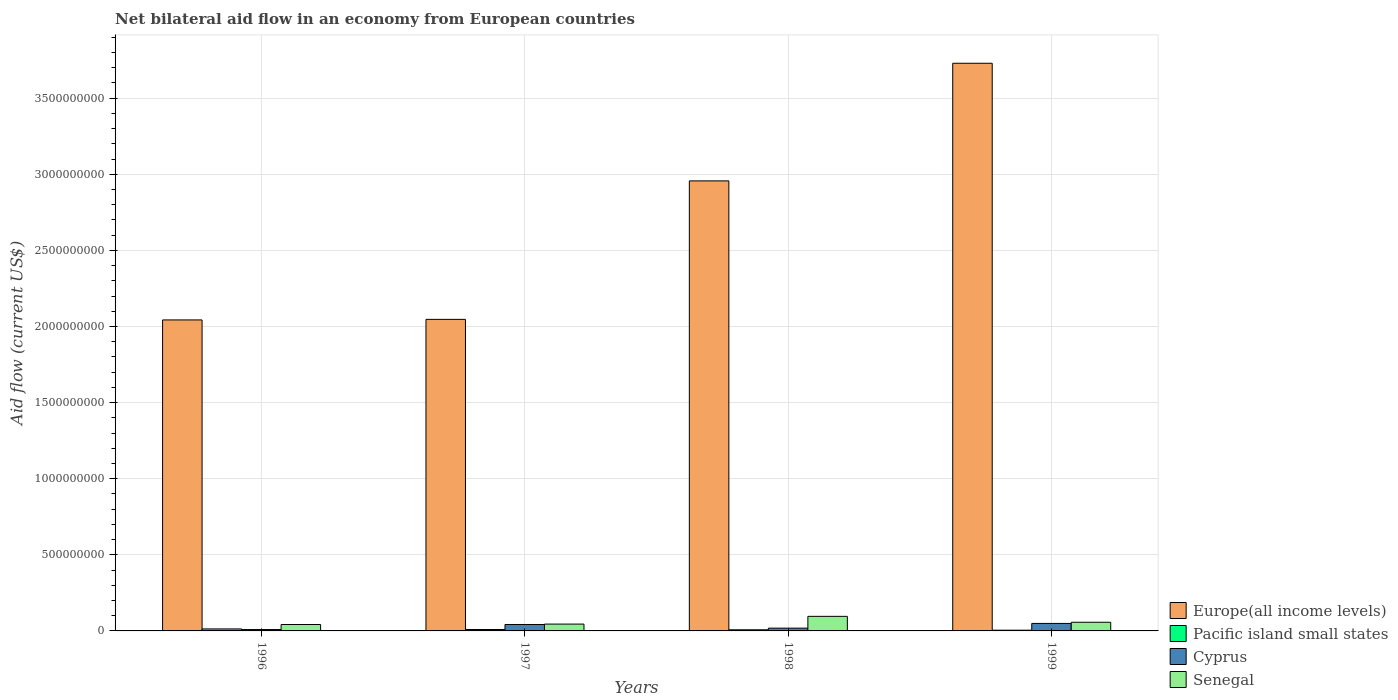How many different coloured bars are there?
Offer a terse response. 4. How many groups of bars are there?
Keep it short and to the point. 4. Are the number of bars per tick equal to the number of legend labels?
Give a very brief answer. Yes. Are the number of bars on each tick of the X-axis equal?
Keep it short and to the point. Yes. In how many cases, is the number of bars for a given year not equal to the number of legend labels?
Provide a succinct answer. 0. What is the net bilateral aid flow in Senegal in 1999?
Ensure brevity in your answer.  5.70e+07. Across all years, what is the maximum net bilateral aid flow in Europe(all income levels)?
Provide a succinct answer. 3.73e+09. Across all years, what is the minimum net bilateral aid flow in Cyprus?
Provide a succinct answer. 8.99e+06. What is the total net bilateral aid flow in Europe(all income levels) in the graph?
Your response must be concise. 1.08e+1. What is the difference between the net bilateral aid flow in Cyprus in 1996 and that in 1998?
Ensure brevity in your answer.  -9.24e+06. What is the difference between the net bilateral aid flow in Pacific island small states in 1998 and the net bilateral aid flow in Europe(all income levels) in 1999?
Ensure brevity in your answer.  -3.72e+09. What is the average net bilateral aid flow in Pacific island small states per year?
Give a very brief answer. 8.67e+06. In the year 1998, what is the difference between the net bilateral aid flow in Pacific island small states and net bilateral aid flow in Senegal?
Your response must be concise. -8.83e+07. In how many years, is the net bilateral aid flow in Cyprus greater than 800000000 US$?
Your answer should be compact. 0. What is the ratio of the net bilateral aid flow in Cyprus in 1996 to that in 1998?
Give a very brief answer. 0.49. Is the net bilateral aid flow in Senegal in 1997 less than that in 1999?
Make the answer very short. Yes. What is the difference between the highest and the second highest net bilateral aid flow in Pacific island small states?
Give a very brief answer. 3.94e+06. What is the difference between the highest and the lowest net bilateral aid flow in Senegal?
Keep it short and to the point. 5.36e+07. Is it the case that in every year, the sum of the net bilateral aid flow in Pacific island small states and net bilateral aid flow in Senegal is greater than the sum of net bilateral aid flow in Europe(all income levels) and net bilateral aid flow in Cyprus?
Make the answer very short. No. What does the 2nd bar from the left in 1999 represents?
Offer a terse response. Pacific island small states. What does the 2nd bar from the right in 1997 represents?
Your answer should be very brief. Cyprus. Is it the case that in every year, the sum of the net bilateral aid flow in Europe(all income levels) and net bilateral aid flow in Cyprus is greater than the net bilateral aid flow in Senegal?
Your response must be concise. Yes. Are all the bars in the graph horizontal?
Provide a succinct answer. No. Are the values on the major ticks of Y-axis written in scientific E-notation?
Your answer should be very brief. No. Does the graph contain any zero values?
Make the answer very short. No. How many legend labels are there?
Your response must be concise. 4. How are the legend labels stacked?
Offer a very short reply. Vertical. What is the title of the graph?
Offer a very short reply. Net bilateral aid flow in an economy from European countries. What is the label or title of the X-axis?
Offer a terse response. Years. What is the Aid flow (current US$) of Europe(all income levels) in 1996?
Provide a short and direct response. 2.04e+09. What is the Aid flow (current US$) of Pacific island small states in 1996?
Make the answer very short. 1.32e+07. What is the Aid flow (current US$) of Cyprus in 1996?
Give a very brief answer. 8.99e+06. What is the Aid flow (current US$) of Senegal in 1996?
Ensure brevity in your answer.  4.21e+07. What is the Aid flow (current US$) in Europe(all income levels) in 1997?
Provide a succinct answer. 2.05e+09. What is the Aid flow (current US$) of Pacific island small states in 1997?
Your answer should be compact. 9.26e+06. What is the Aid flow (current US$) of Cyprus in 1997?
Your answer should be compact. 4.23e+07. What is the Aid flow (current US$) in Senegal in 1997?
Offer a terse response. 4.50e+07. What is the Aid flow (current US$) of Europe(all income levels) in 1998?
Make the answer very short. 2.96e+09. What is the Aid flow (current US$) in Pacific island small states in 1998?
Your answer should be very brief. 7.39e+06. What is the Aid flow (current US$) in Cyprus in 1998?
Your response must be concise. 1.82e+07. What is the Aid flow (current US$) of Senegal in 1998?
Ensure brevity in your answer.  9.57e+07. What is the Aid flow (current US$) of Europe(all income levels) in 1999?
Offer a terse response. 3.73e+09. What is the Aid flow (current US$) in Pacific island small states in 1999?
Your answer should be compact. 4.82e+06. What is the Aid flow (current US$) in Cyprus in 1999?
Offer a very short reply. 4.92e+07. What is the Aid flow (current US$) of Senegal in 1999?
Your response must be concise. 5.70e+07. Across all years, what is the maximum Aid flow (current US$) of Europe(all income levels)?
Offer a terse response. 3.73e+09. Across all years, what is the maximum Aid flow (current US$) of Pacific island small states?
Provide a short and direct response. 1.32e+07. Across all years, what is the maximum Aid flow (current US$) in Cyprus?
Provide a succinct answer. 4.92e+07. Across all years, what is the maximum Aid flow (current US$) in Senegal?
Offer a terse response. 9.57e+07. Across all years, what is the minimum Aid flow (current US$) in Europe(all income levels)?
Make the answer very short. 2.04e+09. Across all years, what is the minimum Aid flow (current US$) in Pacific island small states?
Make the answer very short. 4.82e+06. Across all years, what is the minimum Aid flow (current US$) in Cyprus?
Provide a short and direct response. 8.99e+06. Across all years, what is the minimum Aid flow (current US$) of Senegal?
Make the answer very short. 4.21e+07. What is the total Aid flow (current US$) of Europe(all income levels) in the graph?
Provide a succinct answer. 1.08e+1. What is the total Aid flow (current US$) of Pacific island small states in the graph?
Offer a terse response. 3.47e+07. What is the total Aid flow (current US$) in Cyprus in the graph?
Make the answer very short. 1.19e+08. What is the total Aid flow (current US$) of Senegal in the graph?
Offer a very short reply. 2.40e+08. What is the difference between the Aid flow (current US$) of Europe(all income levels) in 1996 and that in 1997?
Provide a short and direct response. -3.69e+06. What is the difference between the Aid flow (current US$) of Pacific island small states in 1996 and that in 1997?
Offer a very short reply. 3.94e+06. What is the difference between the Aid flow (current US$) in Cyprus in 1996 and that in 1997?
Your response must be concise. -3.33e+07. What is the difference between the Aid flow (current US$) of Senegal in 1996 and that in 1997?
Provide a succinct answer. -2.83e+06. What is the difference between the Aid flow (current US$) of Europe(all income levels) in 1996 and that in 1998?
Provide a short and direct response. -9.14e+08. What is the difference between the Aid flow (current US$) in Pacific island small states in 1996 and that in 1998?
Ensure brevity in your answer.  5.81e+06. What is the difference between the Aid flow (current US$) in Cyprus in 1996 and that in 1998?
Your answer should be very brief. -9.24e+06. What is the difference between the Aid flow (current US$) in Senegal in 1996 and that in 1998?
Give a very brief answer. -5.36e+07. What is the difference between the Aid flow (current US$) in Europe(all income levels) in 1996 and that in 1999?
Offer a very short reply. -1.69e+09. What is the difference between the Aid flow (current US$) of Pacific island small states in 1996 and that in 1999?
Your response must be concise. 8.38e+06. What is the difference between the Aid flow (current US$) of Cyprus in 1996 and that in 1999?
Make the answer very short. -4.02e+07. What is the difference between the Aid flow (current US$) of Senegal in 1996 and that in 1999?
Make the answer very short. -1.48e+07. What is the difference between the Aid flow (current US$) in Europe(all income levels) in 1997 and that in 1998?
Provide a short and direct response. -9.10e+08. What is the difference between the Aid flow (current US$) in Pacific island small states in 1997 and that in 1998?
Your answer should be very brief. 1.87e+06. What is the difference between the Aid flow (current US$) of Cyprus in 1997 and that in 1998?
Offer a very short reply. 2.40e+07. What is the difference between the Aid flow (current US$) in Senegal in 1997 and that in 1998?
Offer a terse response. -5.08e+07. What is the difference between the Aid flow (current US$) in Europe(all income levels) in 1997 and that in 1999?
Offer a very short reply. -1.68e+09. What is the difference between the Aid flow (current US$) in Pacific island small states in 1997 and that in 1999?
Offer a terse response. 4.44e+06. What is the difference between the Aid flow (current US$) in Cyprus in 1997 and that in 1999?
Give a very brief answer. -6.93e+06. What is the difference between the Aid flow (current US$) in Senegal in 1997 and that in 1999?
Ensure brevity in your answer.  -1.20e+07. What is the difference between the Aid flow (current US$) of Europe(all income levels) in 1998 and that in 1999?
Ensure brevity in your answer.  -7.73e+08. What is the difference between the Aid flow (current US$) in Pacific island small states in 1998 and that in 1999?
Your response must be concise. 2.57e+06. What is the difference between the Aid flow (current US$) in Cyprus in 1998 and that in 1999?
Offer a terse response. -3.10e+07. What is the difference between the Aid flow (current US$) of Senegal in 1998 and that in 1999?
Ensure brevity in your answer.  3.88e+07. What is the difference between the Aid flow (current US$) in Europe(all income levels) in 1996 and the Aid flow (current US$) in Pacific island small states in 1997?
Provide a short and direct response. 2.03e+09. What is the difference between the Aid flow (current US$) in Europe(all income levels) in 1996 and the Aid flow (current US$) in Cyprus in 1997?
Provide a succinct answer. 2.00e+09. What is the difference between the Aid flow (current US$) in Europe(all income levels) in 1996 and the Aid flow (current US$) in Senegal in 1997?
Ensure brevity in your answer.  2.00e+09. What is the difference between the Aid flow (current US$) of Pacific island small states in 1996 and the Aid flow (current US$) of Cyprus in 1997?
Keep it short and to the point. -2.91e+07. What is the difference between the Aid flow (current US$) in Pacific island small states in 1996 and the Aid flow (current US$) in Senegal in 1997?
Offer a very short reply. -3.18e+07. What is the difference between the Aid flow (current US$) in Cyprus in 1996 and the Aid flow (current US$) in Senegal in 1997?
Make the answer very short. -3.60e+07. What is the difference between the Aid flow (current US$) of Europe(all income levels) in 1996 and the Aid flow (current US$) of Pacific island small states in 1998?
Ensure brevity in your answer.  2.04e+09. What is the difference between the Aid flow (current US$) in Europe(all income levels) in 1996 and the Aid flow (current US$) in Cyprus in 1998?
Ensure brevity in your answer.  2.03e+09. What is the difference between the Aid flow (current US$) of Europe(all income levels) in 1996 and the Aid flow (current US$) of Senegal in 1998?
Your response must be concise. 1.95e+09. What is the difference between the Aid flow (current US$) in Pacific island small states in 1996 and the Aid flow (current US$) in Cyprus in 1998?
Provide a succinct answer. -5.03e+06. What is the difference between the Aid flow (current US$) in Pacific island small states in 1996 and the Aid flow (current US$) in Senegal in 1998?
Keep it short and to the point. -8.25e+07. What is the difference between the Aid flow (current US$) of Cyprus in 1996 and the Aid flow (current US$) of Senegal in 1998?
Your answer should be compact. -8.67e+07. What is the difference between the Aid flow (current US$) in Europe(all income levels) in 1996 and the Aid flow (current US$) in Pacific island small states in 1999?
Provide a short and direct response. 2.04e+09. What is the difference between the Aid flow (current US$) of Europe(all income levels) in 1996 and the Aid flow (current US$) of Cyprus in 1999?
Keep it short and to the point. 1.99e+09. What is the difference between the Aid flow (current US$) in Europe(all income levels) in 1996 and the Aid flow (current US$) in Senegal in 1999?
Your response must be concise. 1.99e+09. What is the difference between the Aid flow (current US$) of Pacific island small states in 1996 and the Aid flow (current US$) of Cyprus in 1999?
Your answer should be very brief. -3.60e+07. What is the difference between the Aid flow (current US$) in Pacific island small states in 1996 and the Aid flow (current US$) in Senegal in 1999?
Ensure brevity in your answer.  -4.38e+07. What is the difference between the Aid flow (current US$) in Cyprus in 1996 and the Aid flow (current US$) in Senegal in 1999?
Provide a short and direct response. -4.80e+07. What is the difference between the Aid flow (current US$) of Europe(all income levels) in 1997 and the Aid flow (current US$) of Pacific island small states in 1998?
Your answer should be very brief. 2.04e+09. What is the difference between the Aid flow (current US$) of Europe(all income levels) in 1997 and the Aid flow (current US$) of Cyprus in 1998?
Your answer should be compact. 2.03e+09. What is the difference between the Aid flow (current US$) in Europe(all income levels) in 1997 and the Aid flow (current US$) in Senegal in 1998?
Keep it short and to the point. 1.95e+09. What is the difference between the Aid flow (current US$) of Pacific island small states in 1997 and the Aid flow (current US$) of Cyprus in 1998?
Your answer should be very brief. -8.97e+06. What is the difference between the Aid flow (current US$) in Pacific island small states in 1997 and the Aid flow (current US$) in Senegal in 1998?
Ensure brevity in your answer.  -8.65e+07. What is the difference between the Aid flow (current US$) of Cyprus in 1997 and the Aid flow (current US$) of Senegal in 1998?
Ensure brevity in your answer.  -5.35e+07. What is the difference between the Aid flow (current US$) in Europe(all income levels) in 1997 and the Aid flow (current US$) in Pacific island small states in 1999?
Provide a succinct answer. 2.04e+09. What is the difference between the Aid flow (current US$) of Europe(all income levels) in 1997 and the Aid flow (current US$) of Cyprus in 1999?
Provide a succinct answer. 2.00e+09. What is the difference between the Aid flow (current US$) of Europe(all income levels) in 1997 and the Aid flow (current US$) of Senegal in 1999?
Make the answer very short. 1.99e+09. What is the difference between the Aid flow (current US$) of Pacific island small states in 1997 and the Aid flow (current US$) of Cyprus in 1999?
Make the answer very short. -3.99e+07. What is the difference between the Aid flow (current US$) in Pacific island small states in 1997 and the Aid flow (current US$) in Senegal in 1999?
Make the answer very short. -4.77e+07. What is the difference between the Aid flow (current US$) of Cyprus in 1997 and the Aid flow (current US$) of Senegal in 1999?
Make the answer very short. -1.47e+07. What is the difference between the Aid flow (current US$) of Europe(all income levels) in 1998 and the Aid flow (current US$) of Pacific island small states in 1999?
Provide a succinct answer. 2.95e+09. What is the difference between the Aid flow (current US$) in Europe(all income levels) in 1998 and the Aid flow (current US$) in Cyprus in 1999?
Offer a terse response. 2.91e+09. What is the difference between the Aid flow (current US$) in Europe(all income levels) in 1998 and the Aid flow (current US$) in Senegal in 1999?
Provide a succinct answer. 2.90e+09. What is the difference between the Aid flow (current US$) of Pacific island small states in 1998 and the Aid flow (current US$) of Cyprus in 1999?
Your response must be concise. -4.18e+07. What is the difference between the Aid flow (current US$) in Pacific island small states in 1998 and the Aid flow (current US$) in Senegal in 1999?
Keep it short and to the point. -4.96e+07. What is the difference between the Aid flow (current US$) in Cyprus in 1998 and the Aid flow (current US$) in Senegal in 1999?
Ensure brevity in your answer.  -3.87e+07. What is the average Aid flow (current US$) in Europe(all income levels) per year?
Give a very brief answer. 2.69e+09. What is the average Aid flow (current US$) in Pacific island small states per year?
Provide a short and direct response. 8.67e+06. What is the average Aid flow (current US$) of Cyprus per year?
Offer a very short reply. 2.97e+07. What is the average Aid flow (current US$) in Senegal per year?
Your answer should be very brief. 5.99e+07. In the year 1996, what is the difference between the Aid flow (current US$) of Europe(all income levels) and Aid flow (current US$) of Pacific island small states?
Ensure brevity in your answer.  2.03e+09. In the year 1996, what is the difference between the Aid flow (current US$) in Europe(all income levels) and Aid flow (current US$) in Cyprus?
Your answer should be very brief. 2.03e+09. In the year 1996, what is the difference between the Aid flow (current US$) of Europe(all income levels) and Aid flow (current US$) of Senegal?
Provide a short and direct response. 2.00e+09. In the year 1996, what is the difference between the Aid flow (current US$) in Pacific island small states and Aid flow (current US$) in Cyprus?
Offer a terse response. 4.21e+06. In the year 1996, what is the difference between the Aid flow (current US$) in Pacific island small states and Aid flow (current US$) in Senegal?
Your answer should be compact. -2.89e+07. In the year 1996, what is the difference between the Aid flow (current US$) in Cyprus and Aid flow (current US$) in Senegal?
Ensure brevity in your answer.  -3.31e+07. In the year 1997, what is the difference between the Aid flow (current US$) in Europe(all income levels) and Aid flow (current US$) in Pacific island small states?
Offer a terse response. 2.04e+09. In the year 1997, what is the difference between the Aid flow (current US$) in Europe(all income levels) and Aid flow (current US$) in Cyprus?
Keep it short and to the point. 2.00e+09. In the year 1997, what is the difference between the Aid flow (current US$) in Europe(all income levels) and Aid flow (current US$) in Senegal?
Provide a succinct answer. 2.00e+09. In the year 1997, what is the difference between the Aid flow (current US$) in Pacific island small states and Aid flow (current US$) in Cyprus?
Give a very brief answer. -3.30e+07. In the year 1997, what is the difference between the Aid flow (current US$) of Pacific island small states and Aid flow (current US$) of Senegal?
Give a very brief answer. -3.57e+07. In the year 1997, what is the difference between the Aid flow (current US$) of Cyprus and Aid flow (current US$) of Senegal?
Ensure brevity in your answer.  -2.70e+06. In the year 1998, what is the difference between the Aid flow (current US$) of Europe(all income levels) and Aid flow (current US$) of Pacific island small states?
Offer a very short reply. 2.95e+09. In the year 1998, what is the difference between the Aid flow (current US$) of Europe(all income levels) and Aid flow (current US$) of Cyprus?
Keep it short and to the point. 2.94e+09. In the year 1998, what is the difference between the Aid flow (current US$) of Europe(all income levels) and Aid flow (current US$) of Senegal?
Keep it short and to the point. 2.86e+09. In the year 1998, what is the difference between the Aid flow (current US$) of Pacific island small states and Aid flow (current US$) of Cyprus?
Provide a succinct answer. -1.08e+07. In the year 1998, what is the difference between the Aid flow (current US$) in Pacific island small states and Aid flow (current US$) in Senegal?
Offer a very short reply. -8.83e+07. In the year 1998, what is the difference between the Aid flow (current US$) in Cyprus and Aid flow (current US$) in Senegal?
Provide a succinct answer. -7.75e+07. In the year 1999, what is the difference between the Aid flow (current US$) of Europe(all income levels) and Aid flow (current US$) of Pacific island small states?
Your answer should be very brief. 3.72e+09. In the year 1999, what is the difference between the Aid flow (current US$) of Europe(all income levels) and Aid flow (current US$) of Cyprus?
Your response must be concise. 3.68e+09. In the year 1999, what is the difference between the Aid flow (current US$) of Europe(all income levels) and Aid flow (current US$) of Senegal?
Your answer should be very brief. 3.67e+09. In the year 1999, what is the difference between the Aid flow (current US$) in Pacific island small states and Aid flow (current US$) in Cyprus?
Your answer should be compact. -4.44e+07. In the year 1999, what is the difference between the Aid flow (current US$) in Pacific island small states and Aid flow (current US$) in Senegal?
Provide a short and direct response. -5.21e+07. In the year 1999, what is the difference between the Aid flow (current US$) in Cyprus and Aid flow (current US$) in Senegal?
Ensure brevity in your answer.  -7.76e+06. What is the ratio of the Aid flow (current US$) of Pacific island small states in 1996 to that in 1997?
Make the answer very short. 1.43. What is the ratio of the Aid flow (current US$) in Cyprus in 1996 to that in 1997?
Offer a very short reply. 0.21. What is the ratio of the Aid flow (current US$) in Senegal in 1996 to that in 1997?
Make the answer very short. 0.94. What is the ratio of the Aid flow (current US$) of Europe(all income levels) in 1996 to that in 1998?
Your response must be concise. 0.69. What is the ratio of the Aid flow (current US$) in Pacific island small states in 1996 to that in 1998?
Offer a very short reply. 1.79. What is the ratio of the Aid flow (current US$) in Cyprus in 1996 to that in 1998?
Your answer should be compact. 0.49. What is the ratio of the Aid flow (current US$) in Senegal in 1996 to that in 1998?
Give a very brief answer. 0.44. What is the ratio of the Aid flow (current US$) of Europe(all income levels) in 1996 to that in 1999?
Ensure brevity in your answer.  0.55. What is the ratio of the Aid flow (current US$) of Pacific island small states in 1996 to that in 1999?
Offer a very short reply. 2.74. What is the ratio of the Aid flow (current US$) of Cyprus in 1996 to that in 1999?
Offer a very short reply. 0.18. What is the ratio of the Aid flow (current US$) of Senegal in 1996 to that in 1999?
Your answer should be compact. 0.74. What is the ratio of the Aid flow (current US$) in Europe(all income levels) in 1997 to that in 1998?
Make the answer very short. 0.69. What is the ratio of the Aid flow (current US$) of Pacific island small states in 1997 to that in 1998?
Provide a short and direct response. 1.25. What is the ratio of the Aid flow (current US$) in Cyprus in 1997 to that in 1998?
Ensure brevity in your answer.  2.32. What is the ratio of the Aid flow (current US$) of Senegal in 1997 to that in 1998?
Provide a short and direct response. 0.47. What is the ratio of the Aid flow (current US$) in Europe(all income levels) in 1997 to that in 1999?
Your answer should be very brief. 0.55. What is the ratio of the Aid flow (current US$) of Pacific island small states in 1997 to that in 1999?
Give a very brief answer. 1.92. What is the ratio of the Aid flow (current US$) in Cyprus in 1997 to that in 1999?
Your response must be concise. 0.86. What is the ratio of the Aid flow (current US$) in Senegal in 1997 to that in 1999?
Offer a very short reply. 0.79. What is the ratio of the Aid flow (current US$) in Europe(all income levels) in 1998 to that in 1999?
Your answer should be very brief. 0.79. What is the ratio of the Aid flow (current US$) in Pacific island small states in 1998 to that in 1999?
Keep it short and to the point. 1.53. What is the ratio of the Aid flow (current US$) of Cyprus in 1998 to that in 1999?
Provide a succinct answer. 0.37. What is the ratio of the Aid flow (current US$) of Senegal in 1998 to that in 1999?
Give a very brief answer. 1.68. What is the difference between the highest and the second highest Aid flow (current US$) in Europe(all income levels)?
Give a very brief answer. 7.73e+08. What is the difference between the highest and the second highest Aid flow (current US$) of Pacific island small states?
Give a very brief answer. 3.94e+06. What is the difference between the highest and the second highest Aid flow (current US$) of Cyprus?
Give a very brief answer. 6.93e+06. What is the difference between the highest and the second highest Aid flow (current US$) of Senegal?
Make the answer very short. 3.88e+07. What is the difference between the highest and the lowest Aid flow (current US$) of Europe(all income levels)?
Provide a succinct answer. 1.69e+09. What is the difference between the highest and the lowest Aid flow (current US$) in Pacific island small states?
Give a very brief answer. 8.38e+06. What is the difference between the highest and the lowest Aid flow (current US$) in Cyprus?
Provide a succinct answer. 4.02e+07. What is the difference between the highest and the lowest Aid flow (current US$) of Senegal?
Give a very brief answer. 5.36e+07. 